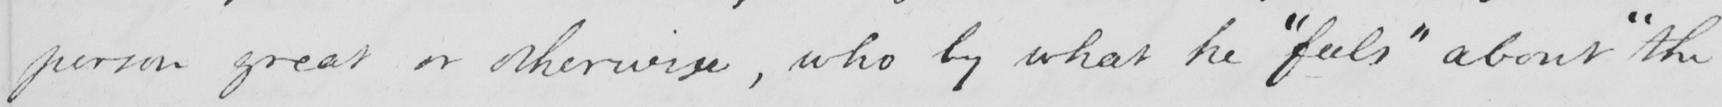Please transcribe the handwritten text in this image. person great or otherwise , who by what he  " feels "  about  " the 